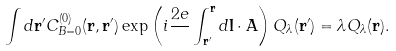Convert formula to latex. <formula><loc_0><loc_0><loc_500><loc_500>\int d { \mathbf r } ^ { \prime } C _ { B = 0 } ^ { ( 0 ) } ( { \mathbf r } , { \mathbf r } ^ { \prime } ) \exp \left ( i \frac { 2 e } { } \int _ { { \mathbf r } ^ { \prime } } ^ { \mathbf r } d { \mathbf l } \cdot { \mathbf A } \right ) Q _ { \lambda } ( { \mathbf r } ^ { \prime } ) = \lambda Q _ { \lambda } ( { \mathbf r } ) .</formula> 